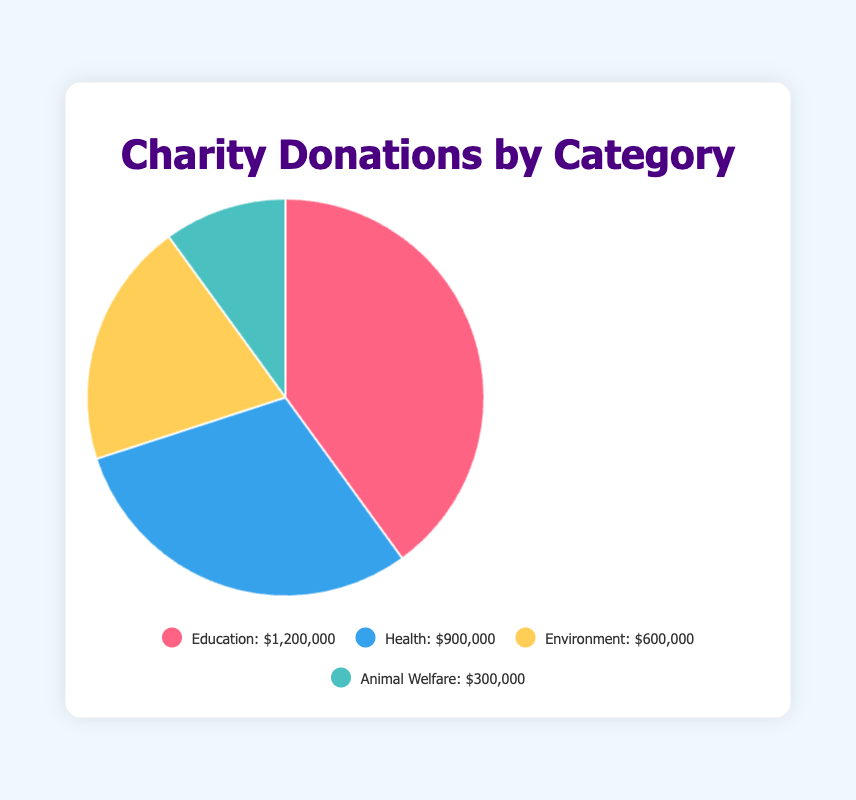Which type of charity received the highest donation? The pie chart shows different donation amounts for each charity type. Education has the largest section of the pie chart, indicating it received the highest donation amount.
Answer: Education Which two types of charities received the least donations? By examining the segments of the pie chart, the smallest parts are for Environment and Animal Welfare.
Answer: Environment and Animal Welfare How much more did Education receive in donations compared to Health? The Education segment shows $1,200,000, and the Health segment shows $900,000. The difference in donation amounts is $1,200,000 - $900,000.
Answer: $300,000 What fraction of the total donations went to Health charities? The total donation amount is $1,200,000 (Education) + $900,000 (Health) + $600,000 (Environment) + $300,000 (Animal Welfare) = $3,000,000. The fraction for Health is $900,000 / $3,000,000.
Answer: 0.3 or 30% If you combine donations for Environment and Animal Welfare, how do they compare to the amount donated to Education? The combined amount for Environment and Animal Welfare is $600,000 + $300,000 = $900,000. The donation amount to Education is $1,200,000. Therefore, the combined amount is less than Education by $1,200,000 - $900,000.
Answer: $300,000 less What is the average donation amount across all charity types? The total donation amount is $3,000,000. Since there are 4 charity types, the average amount is $3,000,000 / 4.
Answer: $750,000 Which color represents the category that received the smallest donation amount? The pie chart assigns different colors to each segment. The smallest segment corresponding to Animal Welfare is colored blue.
Answer: Blue Is the donation amount to Health greater than the combined donations to Environment and Animal Welfare? The donation amount to Health is $900,000. The combined donations to Environment and Animal Welfare is $600,000 + $300,000 = $900,000. Since $900,000 is equal to $900,000.
Answer: No What percentage of the total donations went to Education charities? The total donation amount is $3,000,000. The amount for Education is $1,200,000. The percentage is ($1,200,000 / $3,000,000) * 100.
Answer: 40% What is the combined total of donations for Health and Education charities? The donation amount for Health is $900,000 and for Education is $1,200,000. The combined total is $900,000 + $1,200,000.
Answer: $2,100,000 